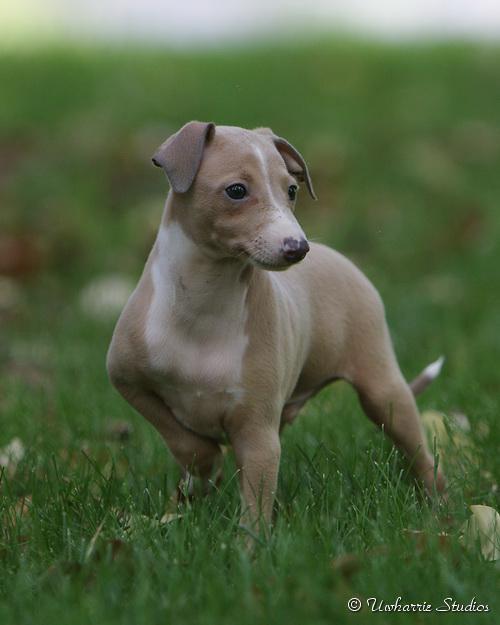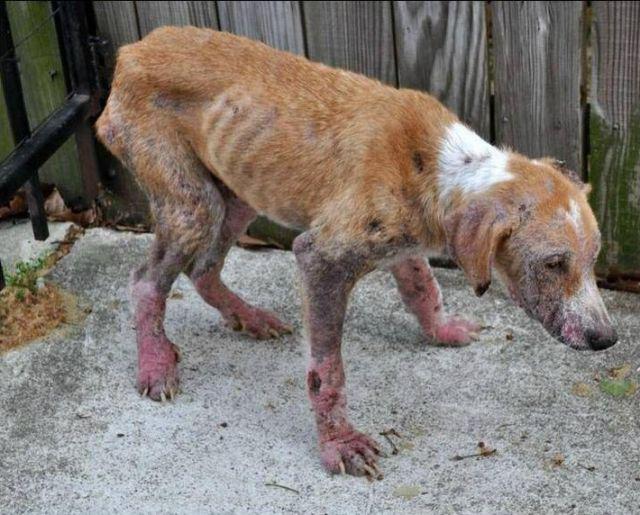The first image is the image on the left, the second image is the image on the right. Evaluate the accuracy of this statement regarding the images: "Left image shows a dog standing on green grass.". Is it true? Answer yes or no. Yes. The first image is the image on the left, the second image is the image on the right. Considering the images on both sides, is "the dog in the image on the left is standing on grass" valid? Answer yes or no. Yes. 